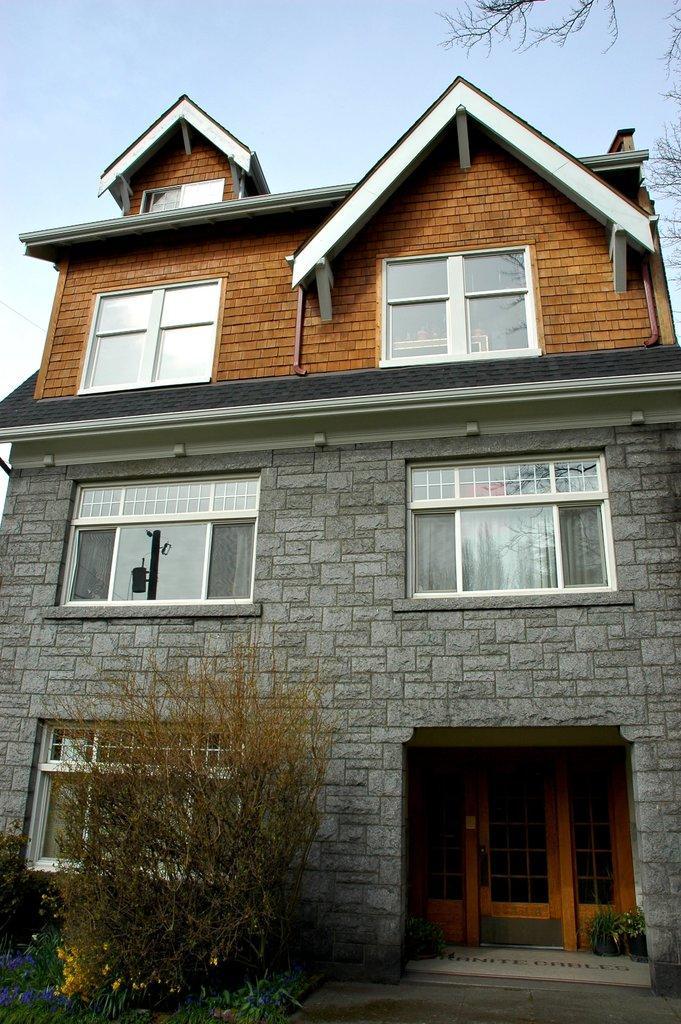In one or two sentences, can you explain what this image depicts? At the center of the image there is a building, in front of the building there are a few plants, flowers and a tree and on the both sides of the door, there are two plant pots. In the background is the sky. 